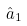Convert formula to latex. <formula><loc_0><loc_0><loc_500><loc_500>\hat { a } _ { 1 }</formula> 